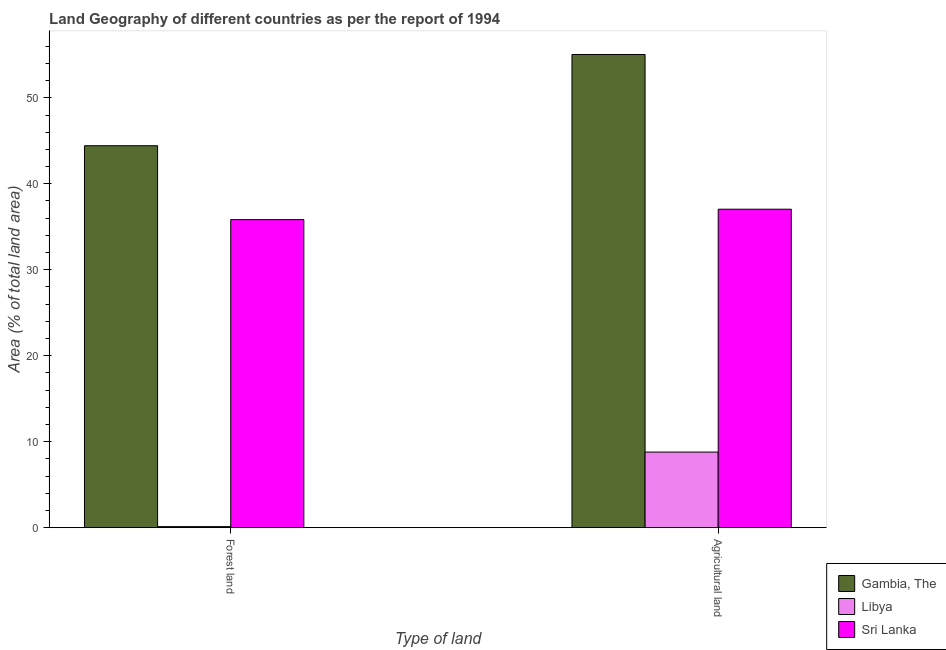How many different coloured bars are there?
Your response must be concise. 3. How many groups of bars are there?
Ensure brevity in your answer.  2. Are the number of bars per tick equal to the number of legend labels?
Keep it short and to the point. Yes. How many bars are there on the 2nd tick from the right?
Make the answer very short. 3. What is the label of the 2nd group of bars from the left?
Give a very brief answer. Agricultural land. What is the percentage of land area under agriculture in Gambia, The?
Your response must be concise. 55.04. Across all countries, what is the maximum percentage of land area under agriculture?
Offer a terse response. 55.04. Across all countries, what is the minimum percentage of land area under agriculture?
Give a very brief answer. 8.79. In which country was the percentage of land area under agriculture maximum?
Your answer should be very brief. Gambia, The. In which country was the percentage of land area under forests minimum?
Provide a succinct answer. Libya. What is the total percentage of land area under agriculture in the graph?
Give a very brief answer. 100.88. What is the difference between the percentage of land area under forests in Sri Lanka and that in Libya?
Your answer should be compact. 35.71. What is the difference between the percentage of land area under forests in Sri Lanka and the percentage of land area under agriculture in Libya?
Your answer should be compact. 27.04. What is the average percentage of land area under agriculture per country?
Provide a short and direct response. 33.63. What is the difference between the percentage of land area under forests and percentage of land area under agriculture in Sri Lanka?
Your answer should be compact. -1.21. In how many countries, is the percentage of land area under agriculture greater than 50 %?
Your answer should be very brief. 1. What is the ratio of the percentage of land area under agriculture in Gambia, The to that in Libya?
Give a very brief answer. 6.26. What does the 3rd bar from the left in Forest land represents?
Keep it short and to the point. Sri Lanka. What does the 2nd bar from the right in Agricultural land represents?
Your response must be concise. Libya. How many bars are there?
Your answer should be compact. 6. What is the difference between two consecutive major ticks on the Y-axis?
Ensure brevity in your answer.  10. Are the values on the major ticks of Y-axis written in scientific E-notation?
Your answer should be compact. No. Does the graph contain any zero values?
Your answer should be very brief. No. Does the graph contain grids?
Your response must be concise. No. Where does the legend appear in the graph?
Provide a short and direct response. Bottom right. How many legend labels are there?
Your answer should be compact. 3. How are the legend labels stacked?
Your answer should be compact. Vertical. What is the title of the graph?
Your response must be concise. Land Geography of different countries as per the report of 1994. Does "European Union" appear as one of the legend labels in the graph?
Provide a succinct answer. No. What is the label or title of the X-axis?
Ensure brevity in your answer.  Type of land. What is the label or title of the Y-axis?
Provide a short and direct response. Area (% of total land area). What is the Area (% of total land area) of Gambia, The in Forest land?
Offer a terse response. 44.43. What is the Area (% of total land area) in Libya in Forest land?
Keep it short and to the point. 0.12. What is the Area (% of total land area) of Sri Lanka in Forest land?
Ensure brevity in your answer.  35.83. What is the Area (% of total land area) in Gambia, The in Agricultural land?
Your response must be concise. 55.04. What is the Area (% of total land area) in Libya in Agricultural land?
Keep it short and to the point. 8.79. What is the Area (% of total land area) of Sri Lanka in Agricultural land?
Keep it short and to the point. 37.04. Across all Type of land, what is the maximum Area (% of total land area) in Gambia, The?
Ensure brevity in your answer.  55.04. Across all Type of land, what is the maximum Area (% of total land area) in Libya?
Provide a succinct answer. 8.79. Across all Type of land, what is the maximum Area (% of total land area) of Sri Lanka?
Keep it short and to the point. 37.04. Across all Type of land, what is the minimum Area (% of total land area) of Gambia, The?
Your answer should be very brief. 44.43. Across all Type of land, what is the minimum Area (% of total land area) of Libya?
Provide a succinct answer. 0.12. Across all Type of land, what is the minimum Area (% of total land area) of Sri Lanka?
Your answer should be compact. 35.83. What is the total Area (% of total land area) in Gambia, The in the graph?
Keep it short and to the point. 99.47. What is the total Area (% of total land area) in Libya in the graph?
Your answer should be very brief. 8.92. What is the total Area (% of total land area) in Sri Lanka in the graph?
Your answer should be very brief. 72.88. What is the difference between the Area (% of total land area) in Gambia, The in Forest land and that in Agricultural land?
Your response must be concise. -10.61. What is the difference between the Area (% of total land area) in Libya in Forest land and that in Agricultural land?
Provide a short and direct response. -8.67. What is the difference between the Area (% of total land area) of Sri Lanka in Forest land and that in Agricultural land?
Keep it short and to the point. -1.21. What is the difference between the Area (% of total land area) of Gambia, The in Forest land and the Area (% of total land area) of Libya in Agricultural land?
Offer a terse response. 35.63. What is the difference between the Area (% of total land area) of Gambia, The in Forest land and the Area (% of total land area) of Sri Lanka in Agricultural land?
Your answer should be very brief. 7.38. What is the difference between the Area (% of total land area) of Libya in Forest land and the Area (% of total land area) of Sri Lanka in Agricultural land?
Keep it short and to the point. -36.92. What is the average Area (% of total land area) in Gambia, The per Type of land?
Provide a succinct answer. 49.73. What is the average Area (% of total land area) in Libya per Type of land?
Your response must be concise. 4.46. What is the average Area (% of total land area) of Sri Lanka per Type of land?
Ensure brevity in your answer.  36.44. What is the difference between the Area (% of total land area) of Gambia, The and Area (% of total land area) of Libya in Forest land?
Provide a short and direct response. 44.3. What is the difference between the Area (% of total land area) in Gambia, The and Area (% of total land area) in Sri Lanka in Forest land?
Offer a very short reply. 8.59. What is the difference between the Area (% of total land area) of Libya and Area (% of total land area) of Sri Lanka in Forest land?
Your answer should be compact. -35.71. What is the difference between the Area (% of total land area) of Gambia, The and Area (% of total land area) of Libya in Agricultural land?
Provide a short and direct response. 46.24. What is the difference between the Area (% of total land area) of Gambia, The and Area (% of total land area) of Sri Lanka in Agricultural land?
Provide a short and direct response. 18. What is the difference between the Area (% of total land area) in Libya and Area (% of total land area) in Sri Lanka in Agricultural land?
Offer a very short reply. -28.25. What is the ratio of the Area (% of total land area) of Gambia, The in Forest land to that in Agricultural land?
Ensure brevity in your answer.  0.81. What is the ratio of the Area (% of total land area) in Libya in Forest land to that in Agricultural land?
Your response must be concise. 0.01. What is the ratio of the Area (% of total land area) of Sri Lanka in Forest land to that in Agricultural land?
Provide a succinct answer. 0.97. What is the difference between the highest and the second highest Area (% of total land area) of Gambia, The?
Keep it short and to the point. 10.61. What is the difference between the highest and the second highest Area (% of total land area) in Libya?
Your answer should be compact. 8.67. What is the difference between the highest and the second highest Area (% of total land area) in Sri Lanka?
Provide a succinct answer. 1.21. What is the difference between the highest and the lowest Area (% of total land area) of Gambia, The?
Give a very brief answer. 10.61. What is the difference between the highest and the lowest Area (% of total land area) in Libya?
Give a very brief answer. 8.67. What is the difference between the highest and the lowest Area (% of total land area) in Sri Lanka?
Keep it short and to the point. 1.21. 